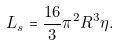Convert formula to latex. <formula><loc_0><loc_0><loc_500><loc_500>L _ { s } = \frac { 1 6 } { 3 } \pi ^ { 2 } R ^ { 3 } \eta .</formula> 